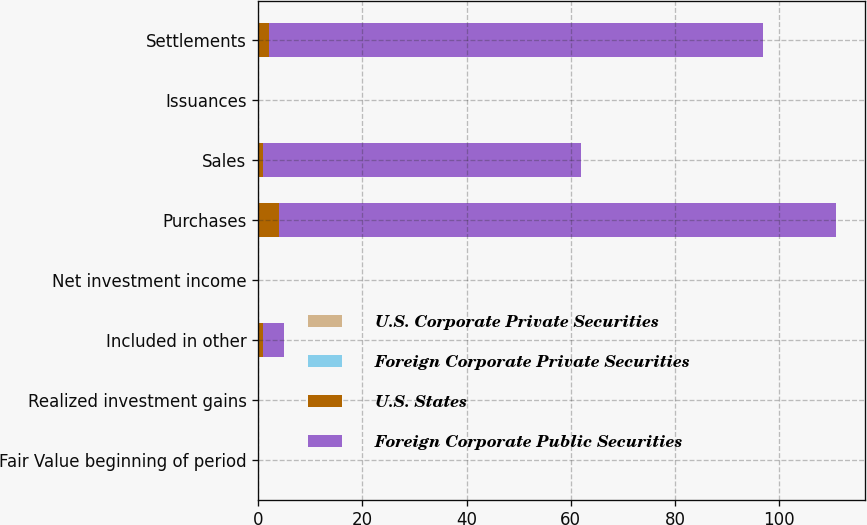<chart> <loc_0><loc_0><loc_500><loc_500><stacked_bar_chart><ecel><fcel>Fair Value beginning of period<fcel>Realized investment gains<fcel>Included in other<fcel>Net investment income<fcel>Purchases<fcel>Sales<fcel>Issuances<fcel>Settlements<nl><fcel>U.S. Corporate Private Securities<fcel>0<fcel>0<fcel>0<fcel>0<fcel>0<fcel>0<fcel>0<fcel>0<nl><fcel>Foreign Corporate Private Securities<fcel>0<fcel>0<fcel>0<fcel>0<fcel>0<fcel>0<fcel>0<fcel>0<nl><fcel>U.S. States<fcel>0<fcel>0<fcel>1<fcel>0<fcel>4<fcel>1<fcel>0<fcel>2<nl><fcel>Foreign Corporate Public Securities<fcel>0<fcel>0<fcel>4<fcel>0<fcel>107<fcel>61<fcel>0<fcel>95<nl></chart> 